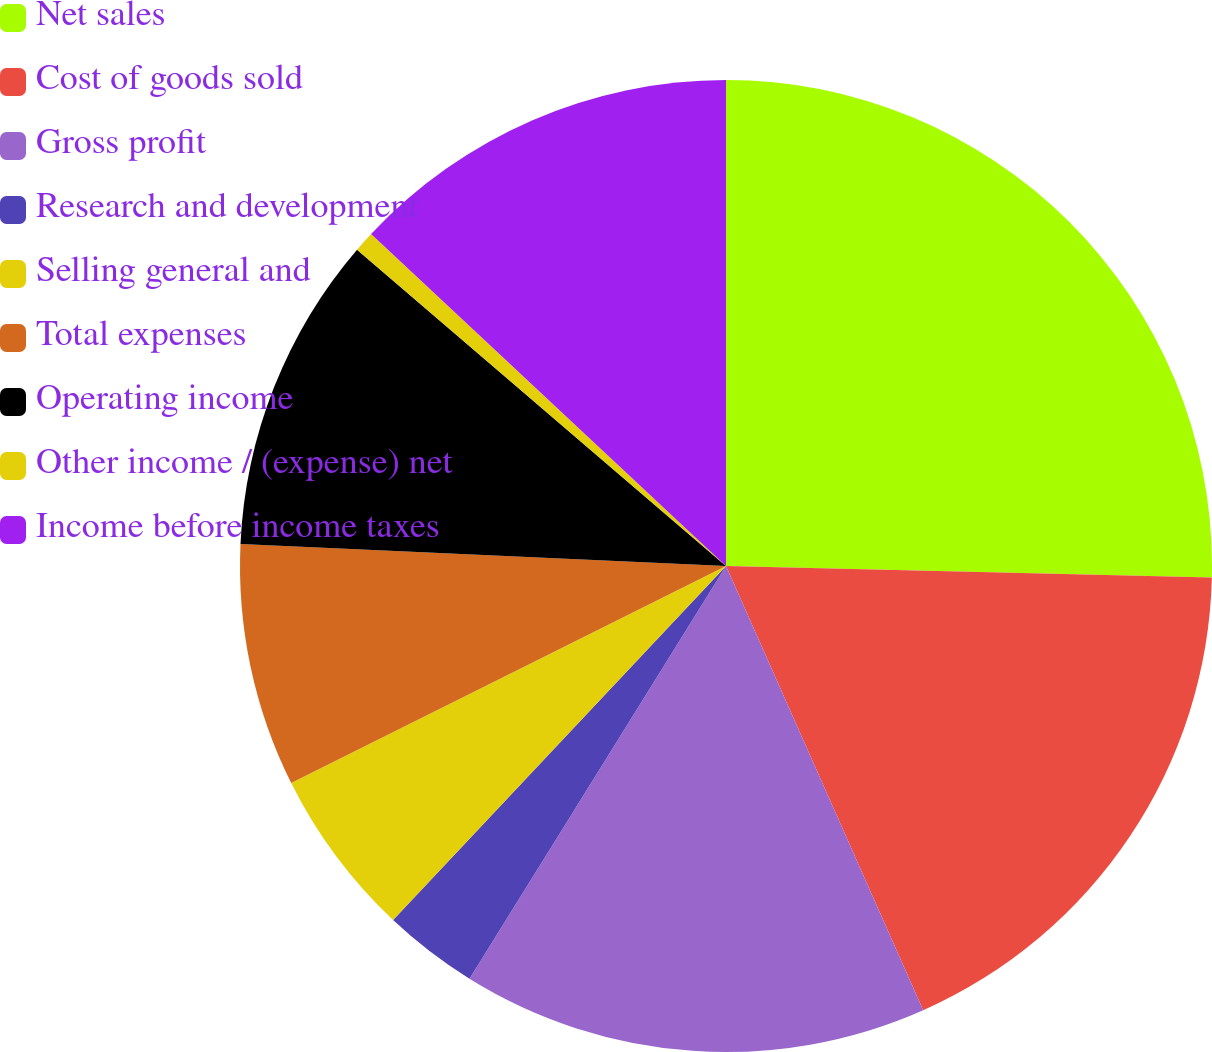Convert chart to OTSL. <chart><loc_0><loc_0><loc_500><loc_500><pie_chart><fcel>Net sales<fcel>Cost of goods sold<fcel>Gross profit<fcel>Research and development<fcel>Selling general and<fcel>Total expenses<fcel>Operating income<fcel>Other income / (expense) net<fcel>Income before income taxes<nl><fcel>25.38%<fcel>17.97%<fcel>15.5%<fcel>3.16%<fcel>5.62%<fcel>8.09%<fcel>10.56%<fcel>0.69%<fcel>13.03%<nl></chart> 